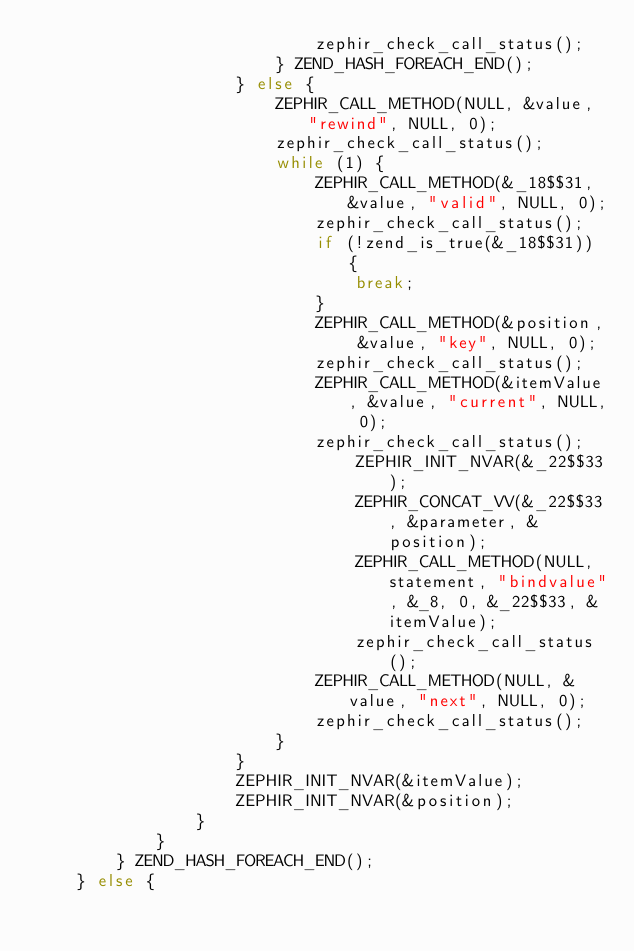<code> <loc_0><loc_0><loc_500><loc_500><_C_>							zephir_check_call_status();
						} ZEND_HASH_FOREACH_END();
					} else {
						ZEPHIR_CALL_METHOD(NULL, &value, "rewind", NULL, 0);
						zephir_check_call_status();
						while (1) {
							ZEPHIR_CALL_METHOD(&_18$$31, &value, "valid", NULL, 0);
							zephir_check_call_status();
							if (!zend_is_true(&_18$$31)) {
								break;
							}
							ZEPHIR_CALL_METHOD(&position, &value, "key", NULL, 0);
							zephir_check_call_status();
							ZEPHIR_CALL_METHOD(&itemValue, &value, "current", NULL, 0);
							zephir_check_call_status();
								ZEPHIR_INIT_NVAR(&_22$$33);
								ZEPHIR_CONCAT_VV(&_22$$33, &parameter, &position);
								ZEPHIR_CALL_METHOD(NULL, statement, "bindvalue", &_8, 0, &_22$$33, &itemValue);
								zephir_check_call_status();
							ZEPHIR_CALL_METHOD(NULL, &value, "next", NULL, 0);
							zephir_check_call_status();
						}
					}
					ZEPHIR_INIT_NVAR(&itemValue);
					ZEPHIR_INIT_NVAR(&position);
				}
			}
		} ZEND_HASH_FOREACH_END();
	} else {</code> 